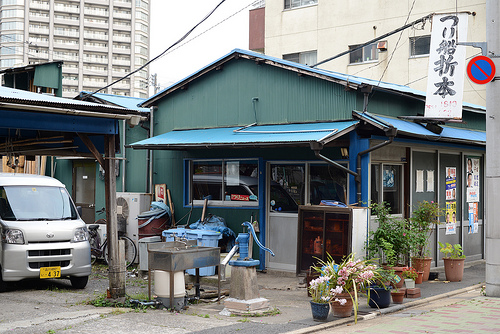<image>
Is there a car in front of the house? Yes. The car is positioned in front of the house, appearing closer to the camera viewpoint. 